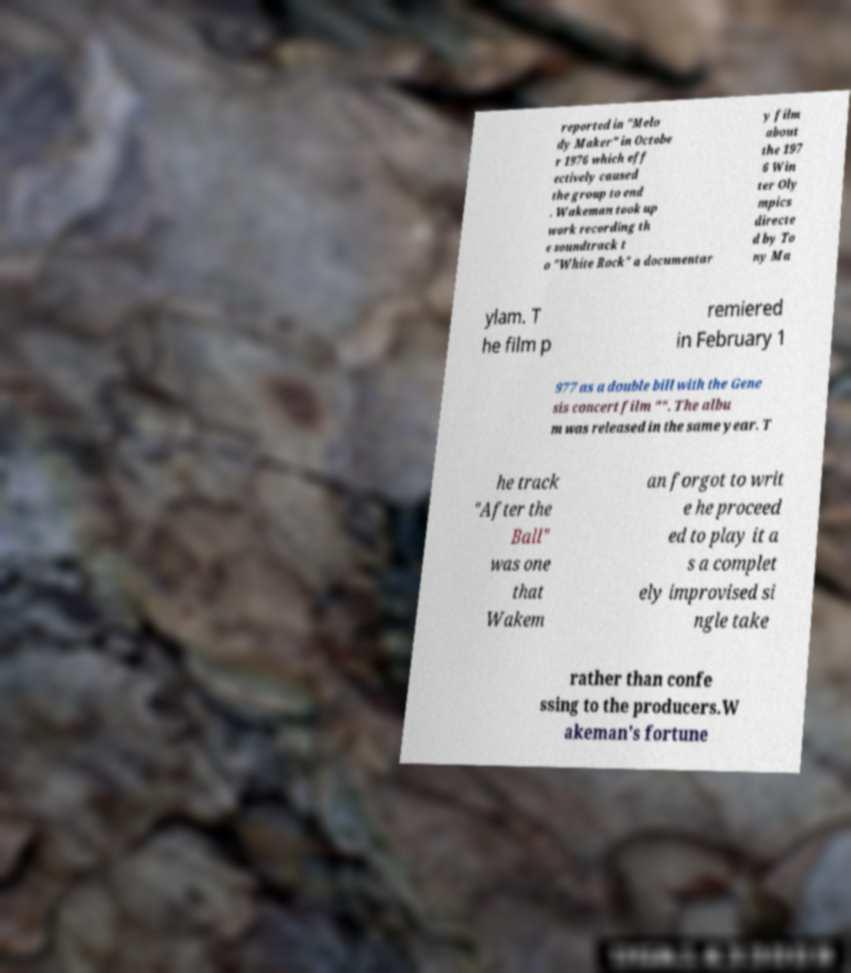I need the written content from this picture converted into text. Can you do that? reported in "Melo dy Maker" in Octobe r 1976 which eff ectively caused the group to end . Wakeman took up work recording th e soundtrack t o "White Rock" a documentar y film about the 197 6 Win ter Oly mpics directe d by To ny Ma ylam. T he film p remiered in February 1 977 as a double bill with the Gene sis concert film "". The albu m was released in the same year. T he track "After the Ball" was one that Wakem an forgot to writ e he proceed ed to play it a s a complet ely improvised si ngle take rather than confe ssing to the producers.W akeman's fortune 